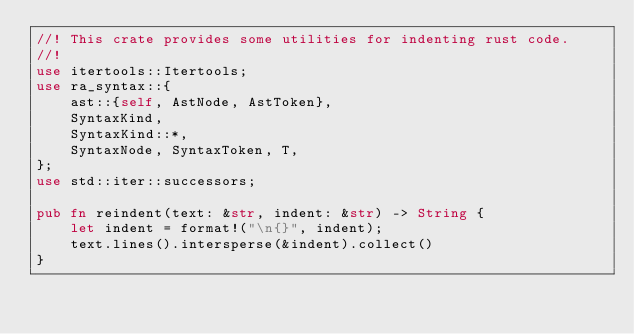Convert code to text. <code><loc_0><loc_0><loc_500><loc_500><_Rust_>//! This crate provides some utilities for indenting rust code.
//!
use itertools::Itertools;
use ra_syntax::{
    ast::{self, AstNode, AstToken},
    SyntaxKind,
    SyntaxKind::*,
    SyntaxNode, SyntaxToken, T,
};
use std::iter::successors;

pub fn reindent(text: &str, indent: &str) -> String {
    let indent = format!("\n{}", indent);
    text.lines().intersperse(&indent).collect()
}
</code> 